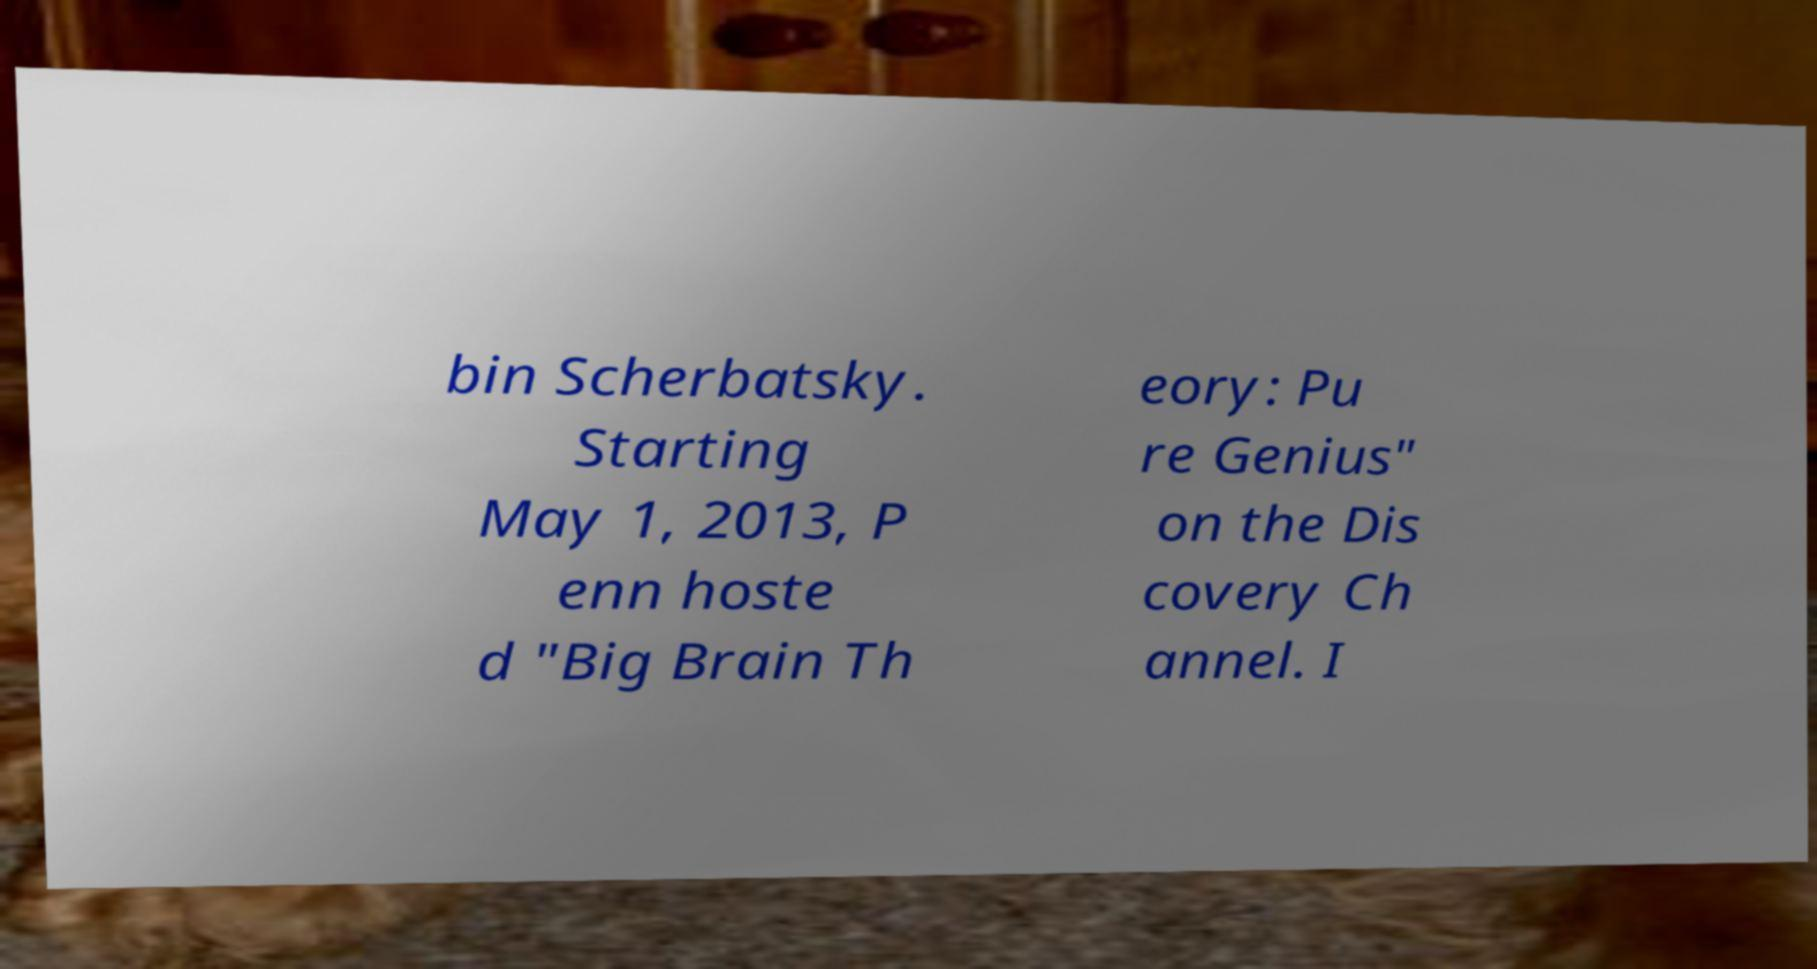Can you accurately transcribe the text from the provided image for me? bin Scherbatsky. Starting May 1, 2013, P enn hoste d "Big Brain Th eory: Pu re Genius" on the Dis covery Ch annel. I 